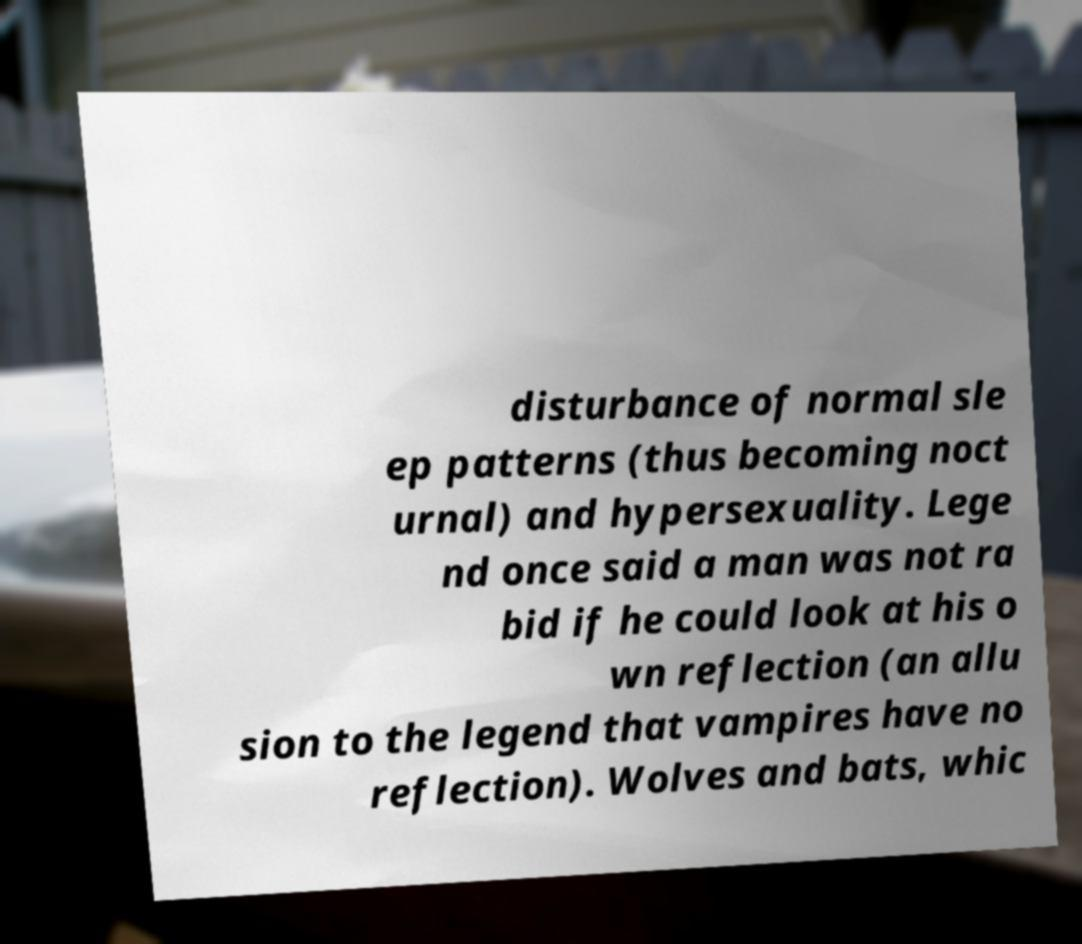Please read and relay the text visible in this image. What does it say? disturbance of normal sle ep patterns (thus becoming noct urnal) and hypersexuality. Lege nd once said a man was not ra bid if he could look at his o wn reflection (an allu sion to the legend that vampires have no reflection). Wolves and bats, whic 